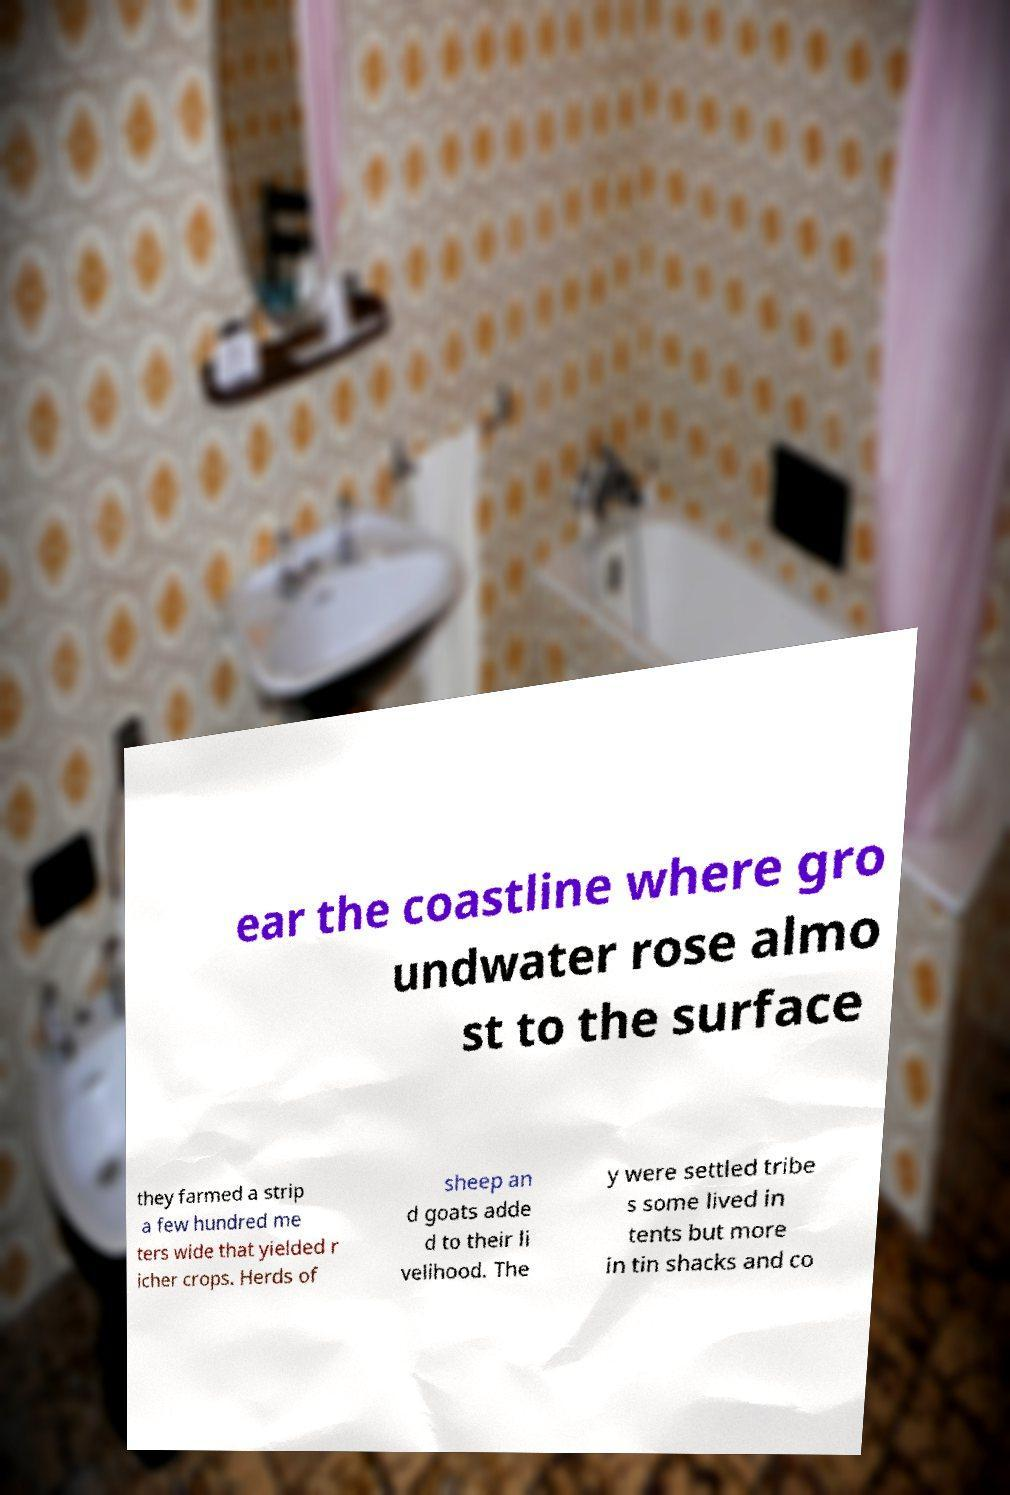Can you read and provide the text displayed in the image?This photo seems to have some interesting text. Can you extract and type it out for me? ear the coastline where gro undwater rose almo st to the surface they farmed a strip a few hundred me ters wide that yielded r icher crops. Herds of sheep an d goats adde d to their li velihood. The y were settled tribe s some lived in tents but more in tin shacks and co 